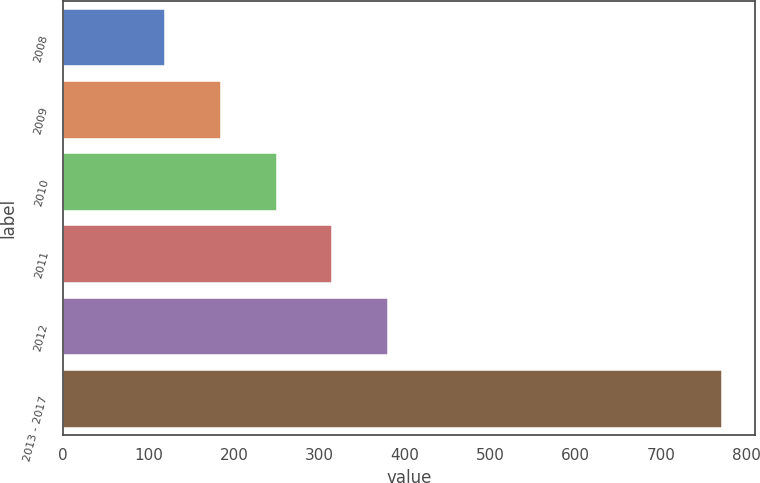<chart> <loc_0><loc_0><loc_500><loc_500><bar_chart><fcel>2008<fcel>2009<fcel>2010<fcel>2011<fcel>2012<fcel>2013 - 2017<nl><fcel>119.6<fcel>184.8<fcel>250<fcel>315.2<fcel>380.4<fcel>771.6<nl></chart> 